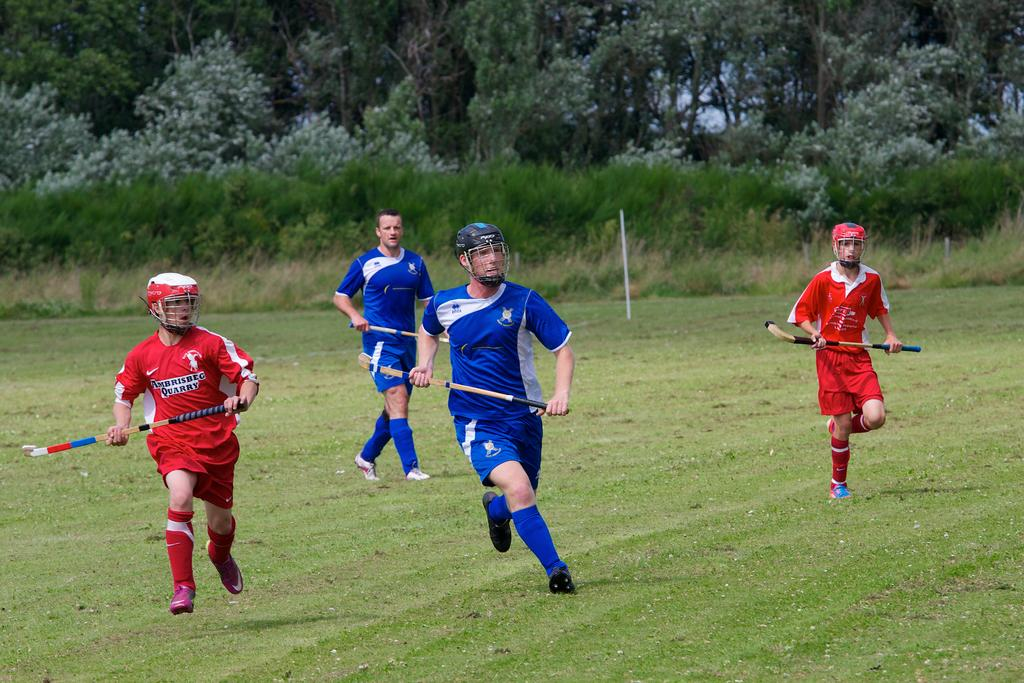Provide a one-sentence caption for the provided image. The red team is wearing jerseys from Ambrisbeg. 